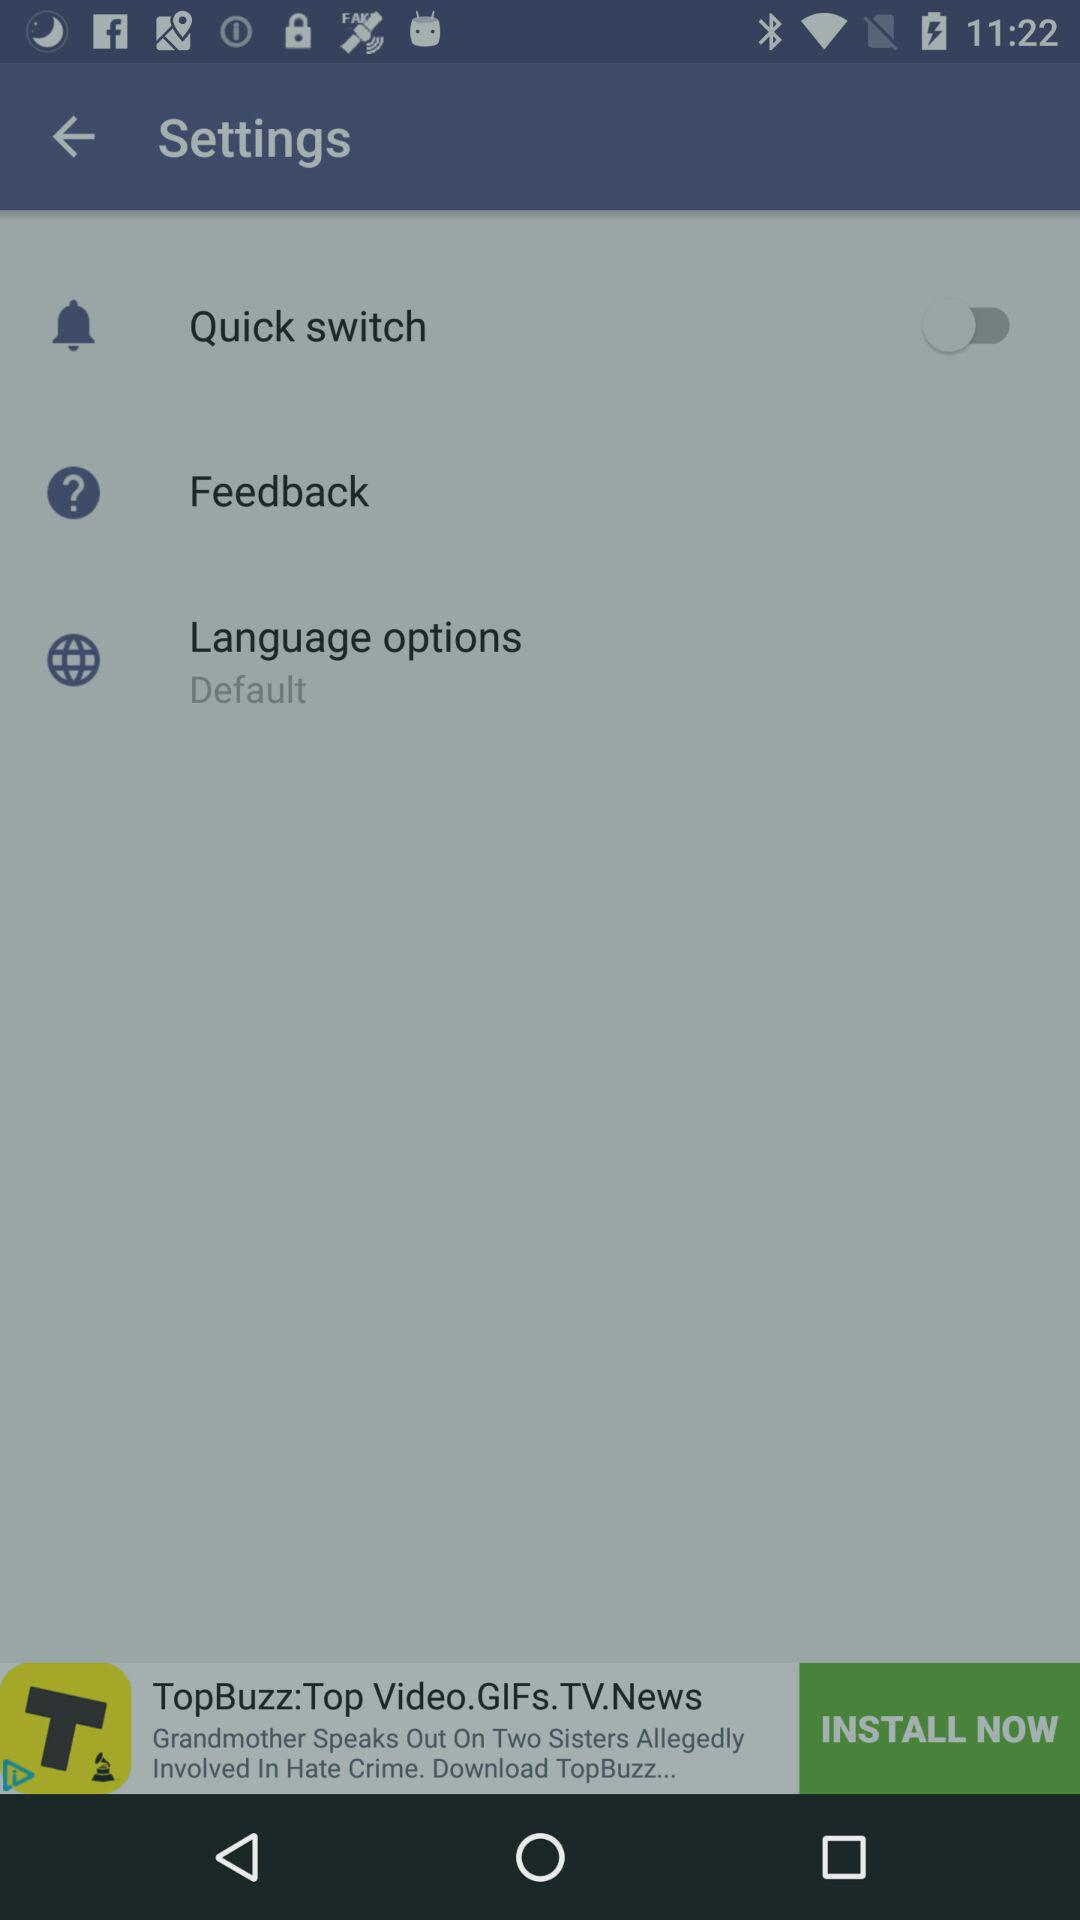What is selected in "Language options"? In "Language options", "Default" is selected. 